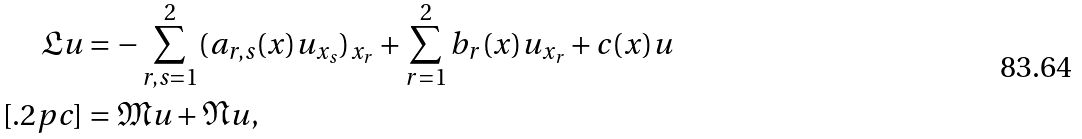Convert formula to latex. <formula><loc_0><loc_0><loc_500><loc_500>\mathfrak { L } u & = - \sum _ { r , s = 1 } ^ { 2 } ( a _ { r , s } ( x ) u _ { x _ { s } } ) _ { x _ { r } } + \sum _ { r = 1 } ^ { 2 } b _ { r } ( x ) u _ { x _ { r } } + c ( x ) u \\ [ . 2 p c ] & = \mathfrak { M } u + \mathfrak { N } u ,</formula> 